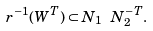Convert formula to latex. <formula><loc_0><loc_0><loc_500><loc_500>r ^ { - 1 } ( W ^ { T } ) \subset N _ { 1 } \ N ^ { - T } _ { 2 } .</formula> 